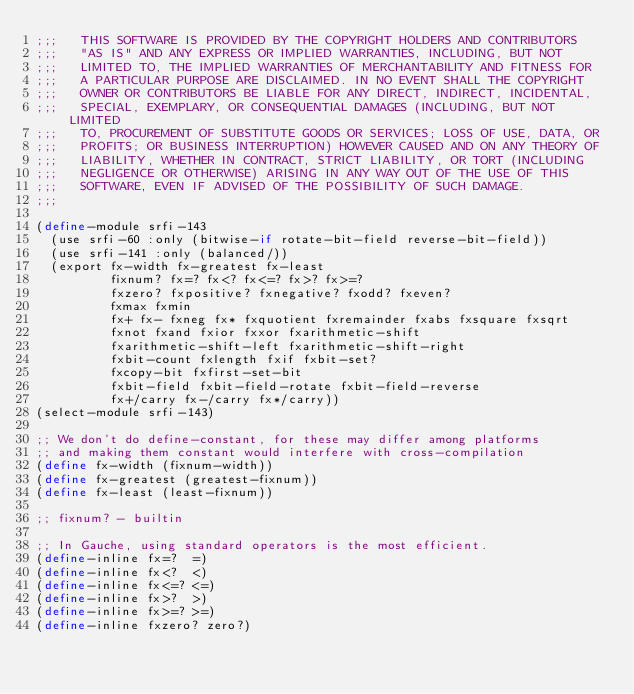Convert code to text. <code><loc_0><loc_0><loc_500><loc_500><_Scheme_>;;;   THIS SOFTWARE IS PROVIDED BY THE COPYRIGHT HOLDERS AND CONTRIBUTORS
;;;   "AS IS" AND ANY EXPRESS OR IMPLIED WARRANTIES, INCLUDING, BUT NOT
;;;   LIMITED TO, THE IMPLIED WARRANTIES OF MERCHANTABILITY AND FITNESS FOR
;;;   A PARTICULAR PURPOSE ARE DISCLAIMED. IN NO EVENT SHALL THE COPYRIGHT
;;;   OWNER OR CONTRIBUTORS BE LIABLE FOR ANY DIRECT, INDIRECT, INCIDENTAL,
;;;   SPECIAL, EXEMPLARY, OR CONSEQUENTIAL DAMAGES (INCLUDING, BUT NOT LIMITED
;;;   TO, PROCUREMENT OF SUBSTITUTE GOODS OR SERVICES; LOSS OF USE, DATA, OR
;;;   PROFITS; OR BUSINESS INTERRUPTION) HOWEVER CAUSED AND ON ANY THEORY OF
;;;   LIABILITY, WHETHER IN CONTRACT, STRICT LIABILITY, OR TORT (INCLUDING
;;;   NEGLIGENCE OR OTHERWISE) ARISING IN ANY WAY OUT OF THE USE OF THIS
;;;   SOFTWARE, EVEN IF ADVISED OF THE POSSIBILITY OF SUCH DAMAGE.
;;;

(define-module srfi-143
  (use srfi-60 :only (bitwise-if rotate-bit-field reverse-bit-field))
  (use srfi-141 :only (balanced/))
  (export fx-width fx-greatest fx-least
          fixnum? fx=? fx<? fx<=? fx>? fx>=?
          fxzero? fxpositive? fxnegative? fxodd? fxeven?
          fxmax fxmin
          fx+ fx- fxneg fx* fxquotient fxremainder fxabs fxsquare fxsqrt
          fxnot fxand fxior fxxor fxarithmetic-shift
          fxarithmetic-shift-left fxarithmetic-shift-right
          fxbit-count fxlength fxif fxbit-set?
          fxcopy-bit fxfirst-set-bit
          fxbit-field fxbit-field-rotate fxbit-field-reverse
          fx+/carry fx-/carry fx*/carry))
(select-module srfi-143)
          
;; We don't do define-constant, for these may differ among platforms
;; and making them constant would interfere with cross-compilation
(define fx-width (fixnum-width))
(define fx-greatest (greatest-fixnum))
(define fx-least (least-fixnum))

;; fixnum? - builtin

;; In Gauche, using standard operators is the most efficient.
(define-inline fx=?  =)
(define-inline fx<?  <)
(define-inline fx<=? <=)
(define-inline fx>?  >)
(define-inline fx>=? >=)
(define-inline fxzero? zero?)</code> 